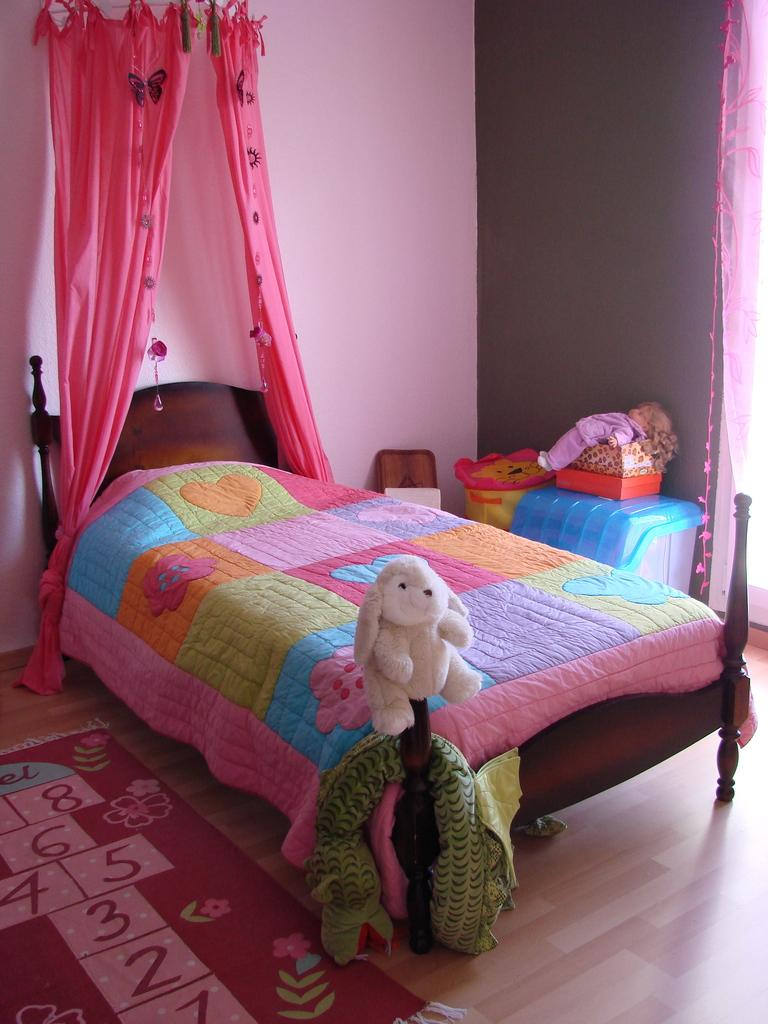What type of furniture is present in the image? There is a bed in the image. What type of toy is present in the image? There is a teddy bear in the image. What type of object is present for storage or holding items in the image? There is a container in the image. What type of window treatment is present in the image? There are curtains in the image. How many knots are tied in the curtains in the image? There is no information about knots in the curtains in the image, so we cannot determine the number of knots. Is there a cat visible in the image? There is no mention of a cat in the provided facts, so we cannot determine if a cat is present in the image. 